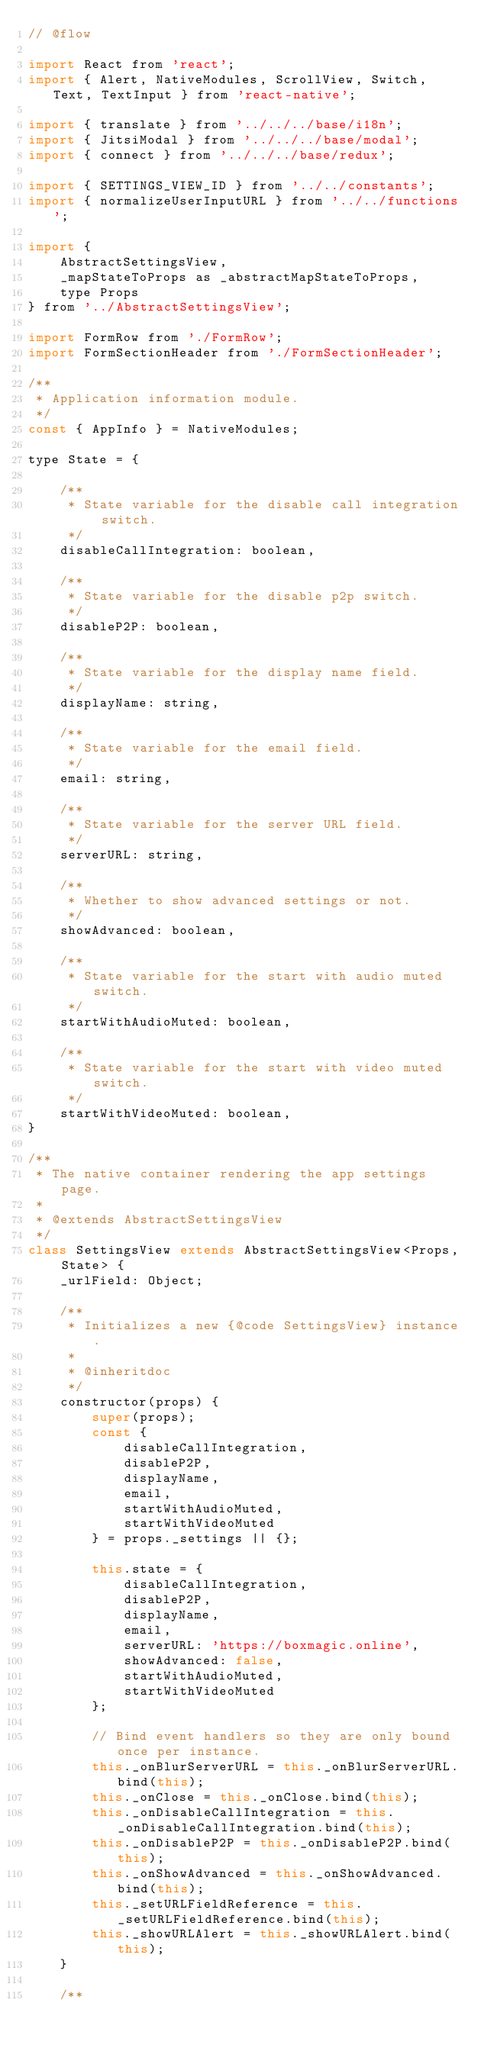<code> <loc_0><loc_0><loc_500><loc_500><_JavaScript_>// @flow

import React from 'react';
import { Alert, NativeModules, ScrollView, Switch, Text, TextInput } from 'react-native';

import { translate } from '../../../base/i18n';
import { JitsiModal } from '../../../base/modal';
import { connect } from '../../../base/redux';

import { SETTINGS_VIEW_ID } from '../../constants';
import { normalizeUserInputURL } from '../../functions';

import {
    AbstractSettingsView,
    _mapStateToProps as _abstractMapStateToProps,
    type Props
} from '../AbstractSettingsView';

import FormRow from './FormRow';
import FormSectionHeader from './FormSectionHeader';

/**
 * Application information module.
 */
const { AppInfo } = NativeModules;

type State = {

    /**
     * State variable for the disable call integration switch.
     */
    disableCallIntegration: boolean,

    /**
     * State variable for the disable p2p switch.
     */
    disableP2P: boolean,

    /**
     * State variable for the display name field.
     */
    displayName: string,

    /**
     * State variable for the email field.
     */
    email: string,

    /**
     * State variable for the server URL field.
     */
    serverURL: string,

    /**
     * Whether to show advanced settings or not.
     */
    showAdvanced: boolean,

    /**
     * State variable for the start with audio muted switch.
     */
    startWithAudioMuted: boolean,

    /**
     * State variable for the start with video muted switch.
     */
    startWithVideoMuted: boolean,
}

/**
 * The native container rendering the app settings page.
 *
 * @extends AbstractSettingsView
 */
class SettingsView extends AbstractSettingsView<Props, State> {
    _urlField: Object;

    /**
     * Initializes a new {@code SettingsView} instance.
     *
     * @inheritdoc
     */
    constructor(props) {
        super(props);
        const {
            disableCallIntegration,
            disableP2P,
            displayName,
            email,
            startWithAudioMuted,
            startWithVideoMuted
        } = props._settings || {};

        this.state = {
            disableCallIntegration,
            disableP2P,
            displayName,
            email,
            serverURL: 'https://boxmagic.online',
            showAdvanced: false,
            startWithAudioMuted,
            startWithVideoMuted
        };

        // Bind event handlers so they are only bound once per instance.
        this._onBlurServerURL = this._onBlurServerURL.bind(this);
        this._onClose = this._onClose.bind(this);
        this._onDisableCallIntegration = this._onDisableCallIntegration.bind(this);
        this._onDisableP2P = this._onDisableP2P.bind(this);
        this._onShowAdvanced = this._onShowAdvanced.bind(this);
        this._setURLFieldReference = this._setURLFieldReference.bind(this);
        this._showURLAlert = this._showURLAlert.bind(this);
    }

    /**</code> 